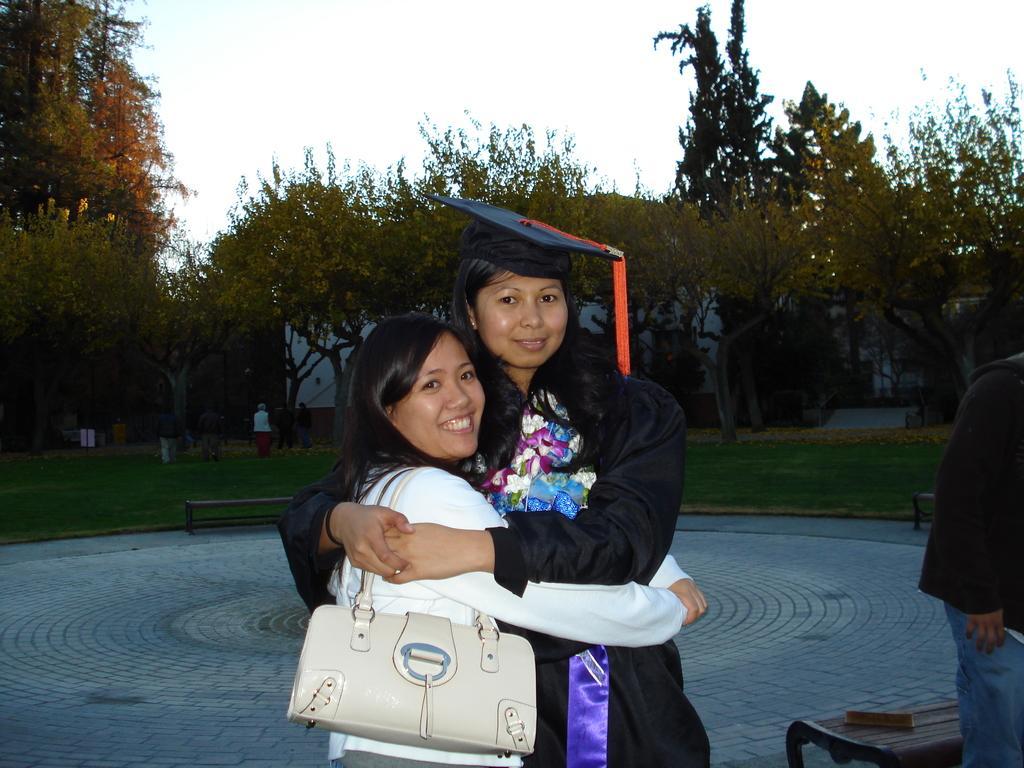Could you give a brief overview of what you see in this image? This image is clicked outside. There are trees in the middle, there is a sky on the top. There are two persons in the middle one is wearing graduation dress, other one is wearing white dress. Both of them are having, both of them are smiling. There is a bench on the bottom right corner. There is a person on the right side. 